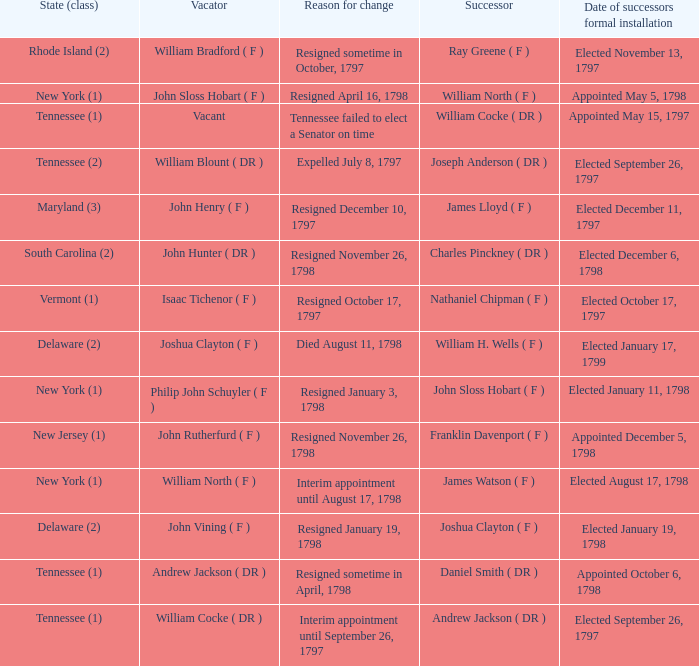What is the number of vacators when the successor was William H. Wells ( F )? 1.0. 